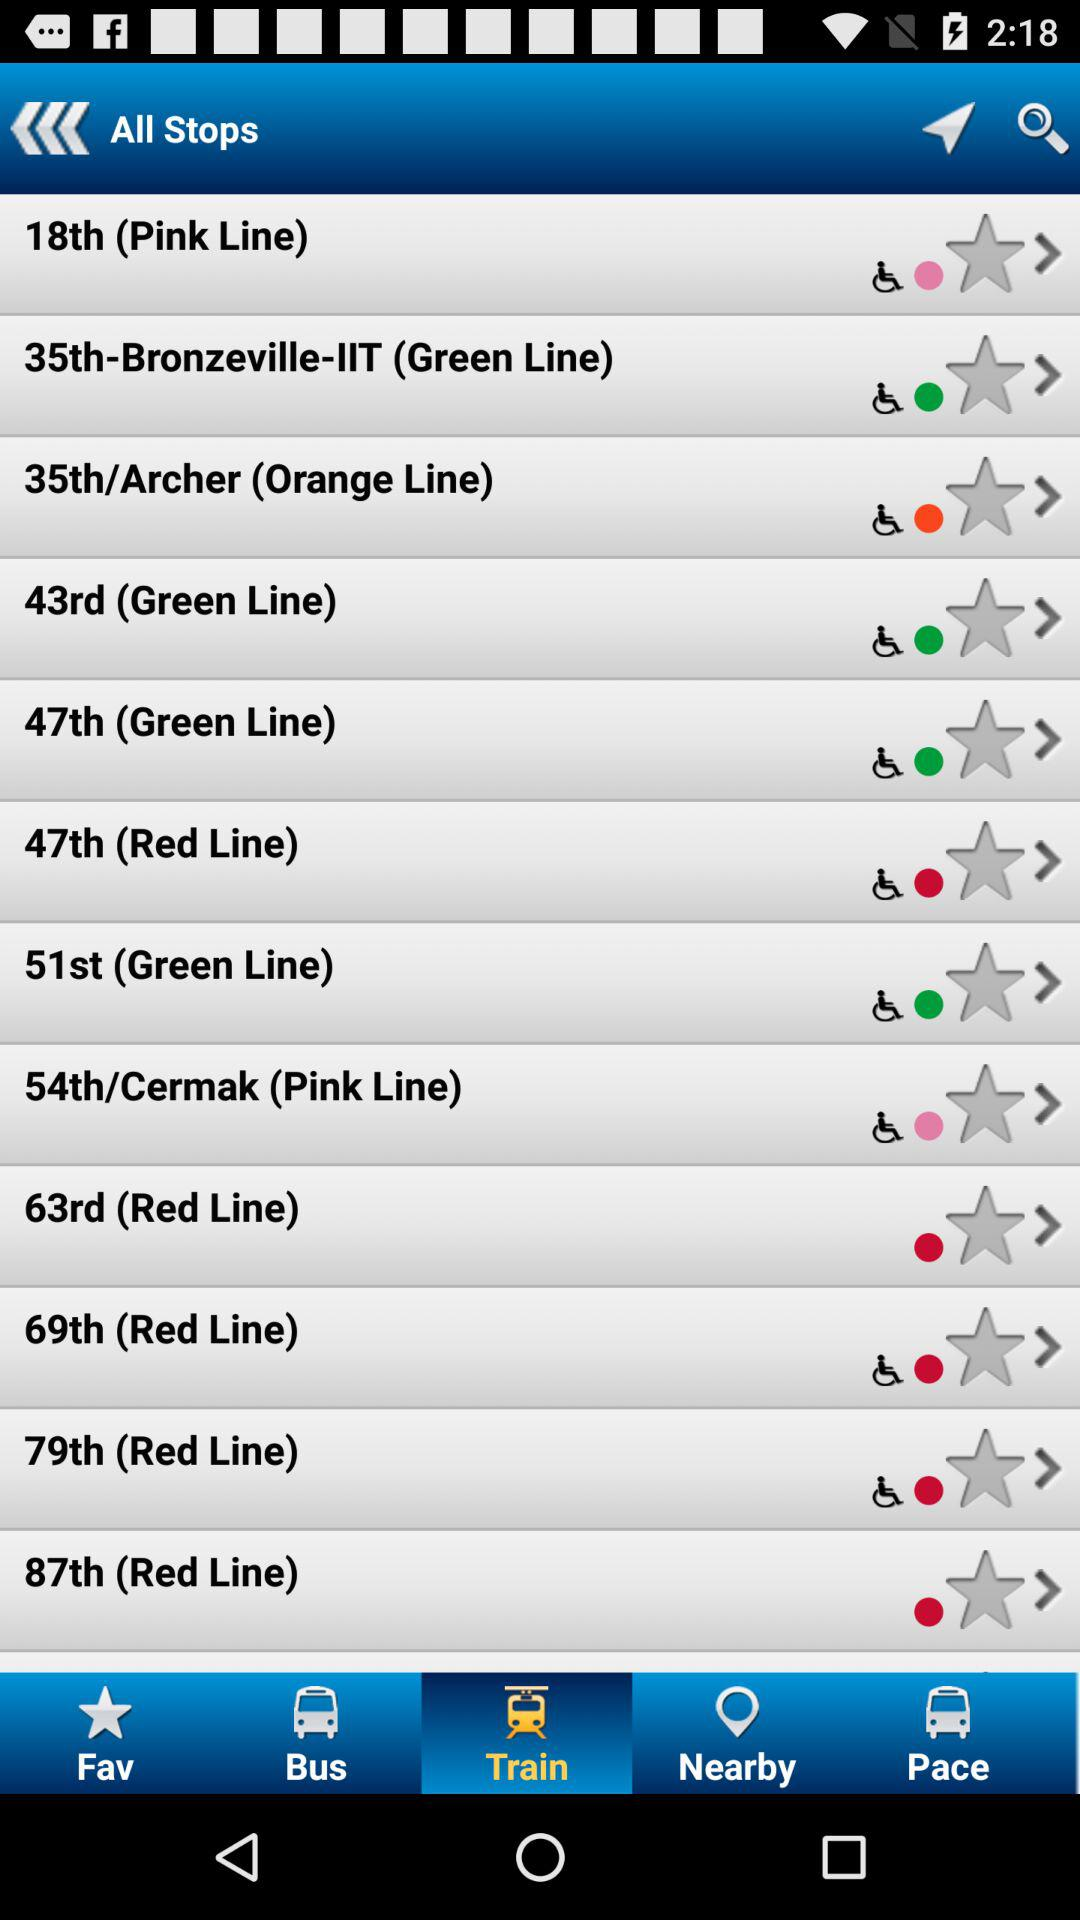What color line does the "18th" stop fall on? The "18th" stop falls on the pink line. 